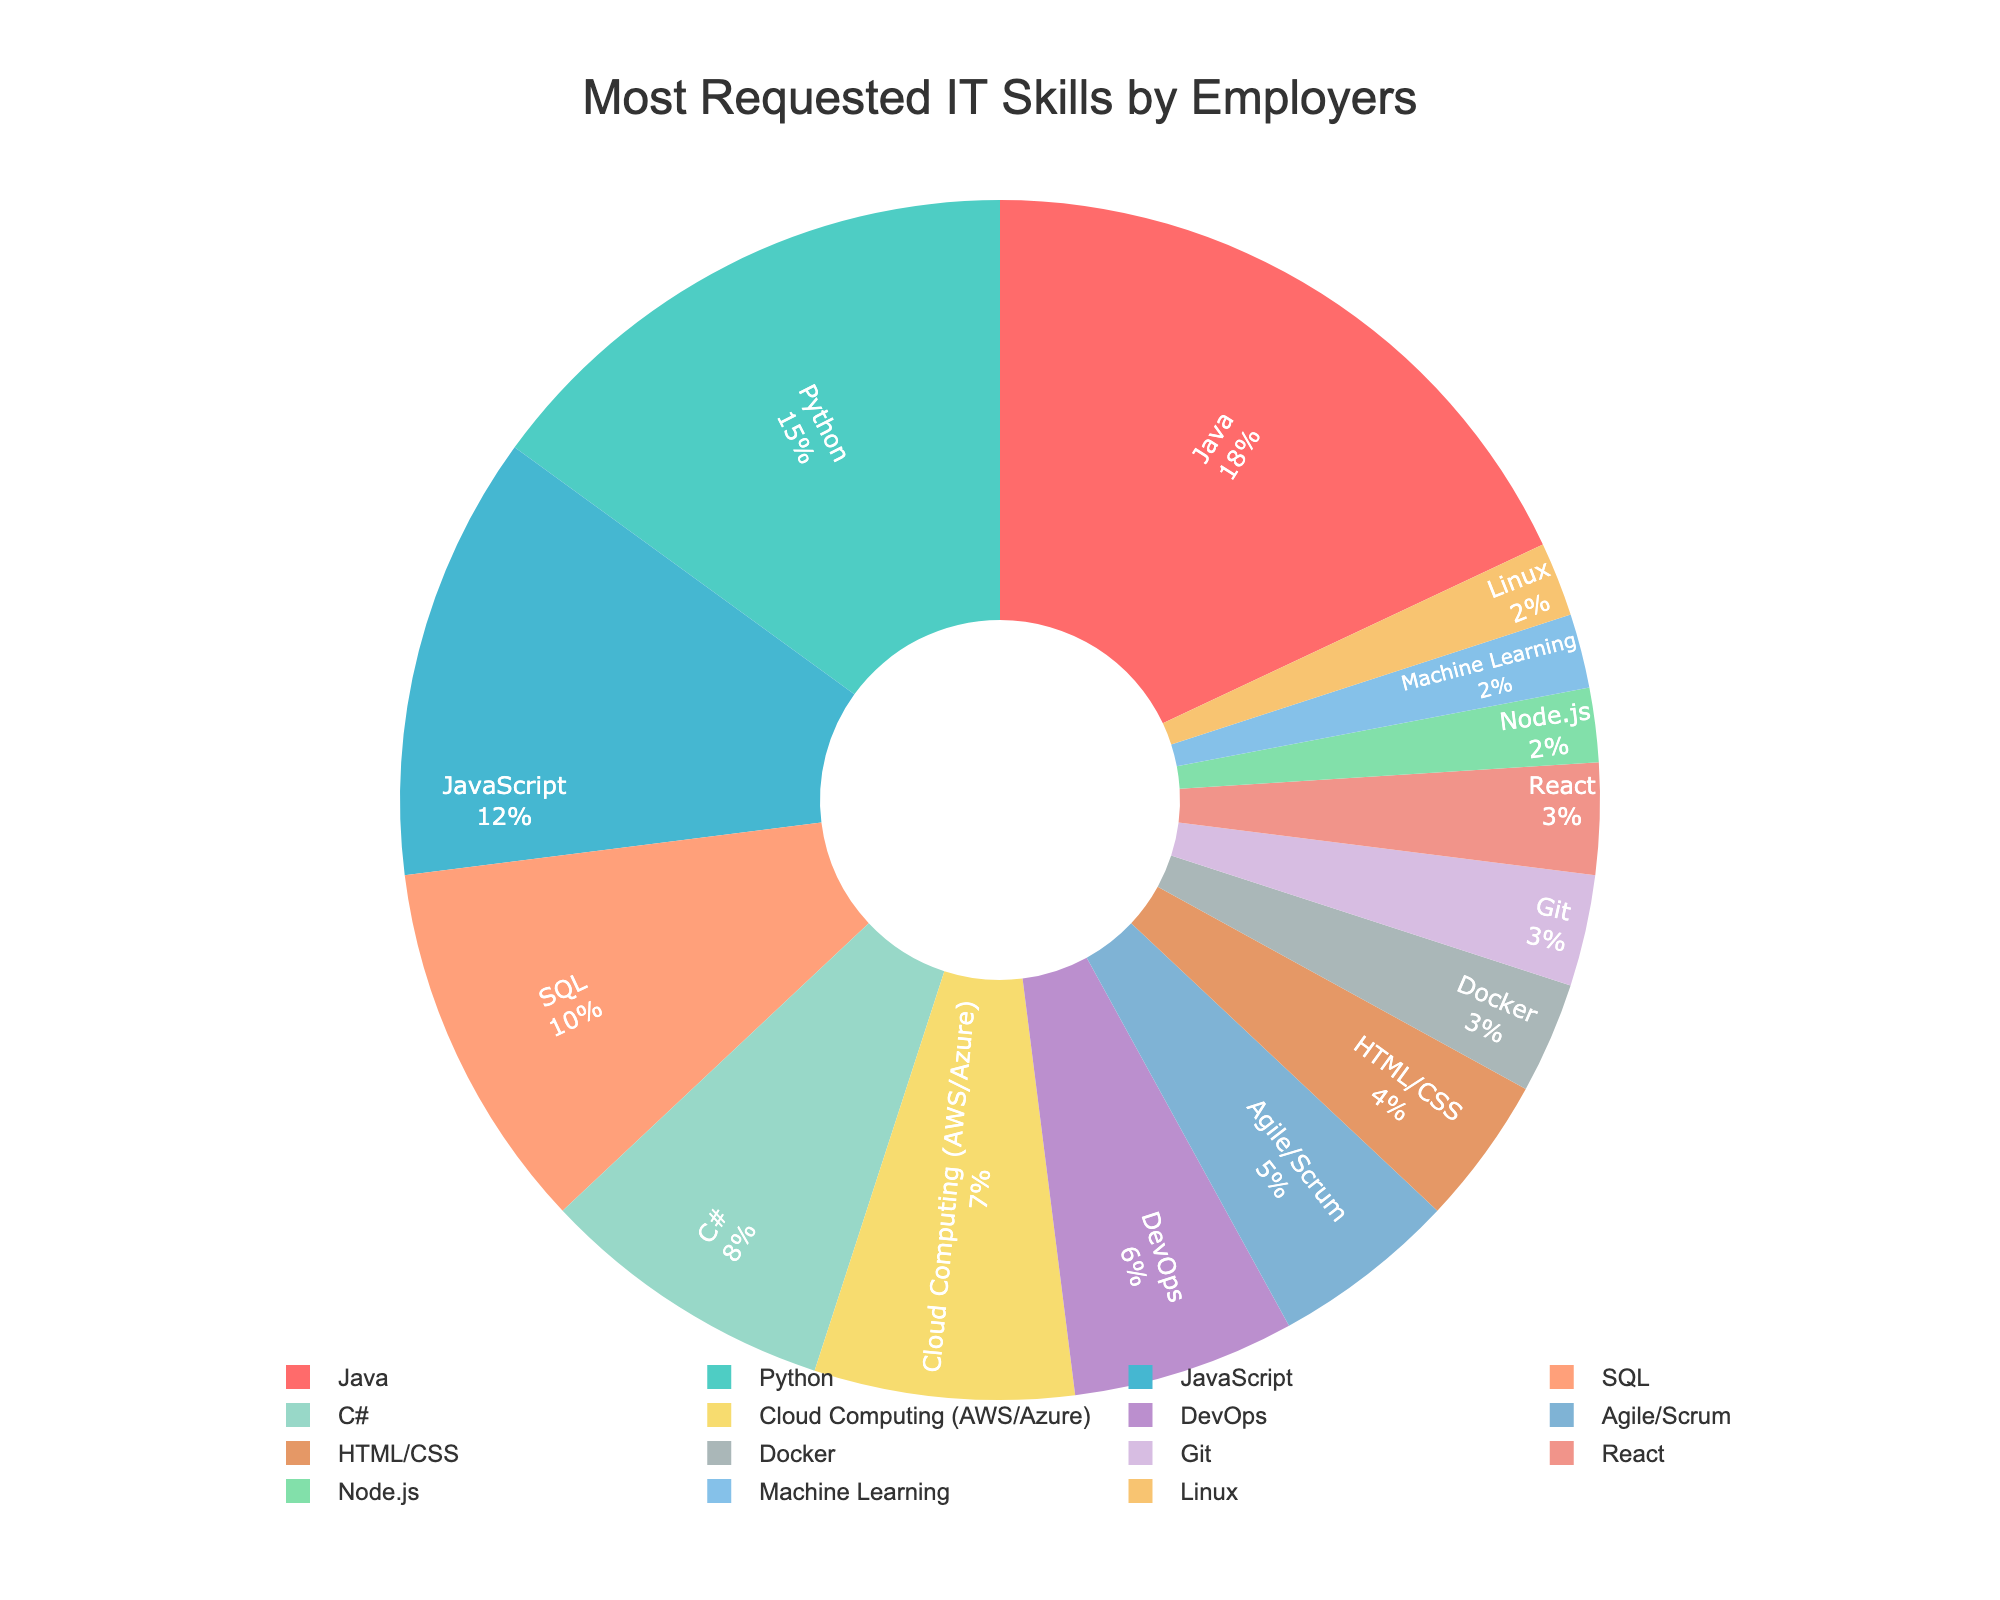What is the most requested skill by employers in the IT industry? The most requested skill is the largest section of the pie chart with the highest percentage.
Answer: Java Which two skills combined make up 25% of the most requested IT skills? Add the percentages of each skill to find which two sum up to 25%. Python (15%) and JavaScript (12%) equals 27%, Python (15%) and SQL (10%) make 25%.
Answer: Python and SQL Which skill is slightly more requested: C# or Cloud Computing (AWS/Azure)? Compare the two percentages. C# has 8% while Cloud Computing (AWS/Azure) has 7%.
Answer: C# What is the combined percentage of skills related to web development (JavaScript, HTML/CSS, React, and Node.js)? Sum the percentages of JavaScript (12%), HTML/CSS (4%), React (3%), and Node.js (2%). This equals 21%.
Answer: 21% Which skill has the same percentage of request as Docker? Identify the two segments with the same size in the pie chart. Docker and Git both have 3%.
Answer: Git What is the total percentage of the top four skills? Add the percentages of the top four skills: Java (18%), Python (15%), JavaScript (12%), and SQL (10%). This sums to 55%.
Answer: 55% Which two skills together are more requested than Cloud Computing (AWS/Azure) but less than Agile/Scrum? Find the skills where their sum is greater than 7% but less than 5%. Docker (3%) and Git (3%) together equal 6%, while Machine Learning (2%) and Linux (2%) together equal 4%. Docker (3%) and Git (3%) are correct.
Answer: Docker and Git Compare the market demand for DevOps and Agile/Scrum skills. Which one is higher? Compare the percentages of DevOps (6%) and Agile/Scrum (5%). DevOps is higher.
Answer: DevOps What percentage of requests are made up by Machine Learning and Linux combined? Add the percentages of Machine Learning (2%) and Linux (2%). This is 4%.
Answer: 4% Identify the skill categories that individually contribute less than 5% but collectively add up to more than 15%. Sum the percentages of skills under 5%: HTML/CSS (4%), Docker (3%), Git (3%), React (3%), Node.js (2%), Machine Learning (2%), and Linux (2%). The total is 19%.
Answer: HTML/CSS, Docker, Git, React, Node.js, Machine Learning, Linux 